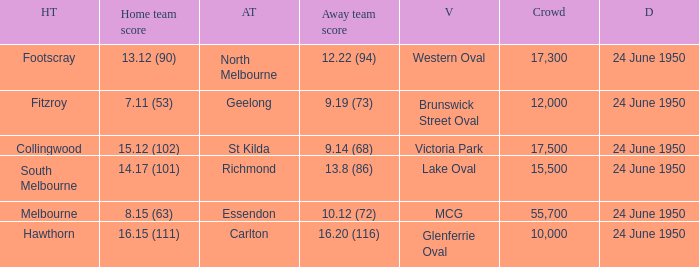Who was the home team for the game where North Melbourne was the away team and the crowd was over 12,000? Footscray. 